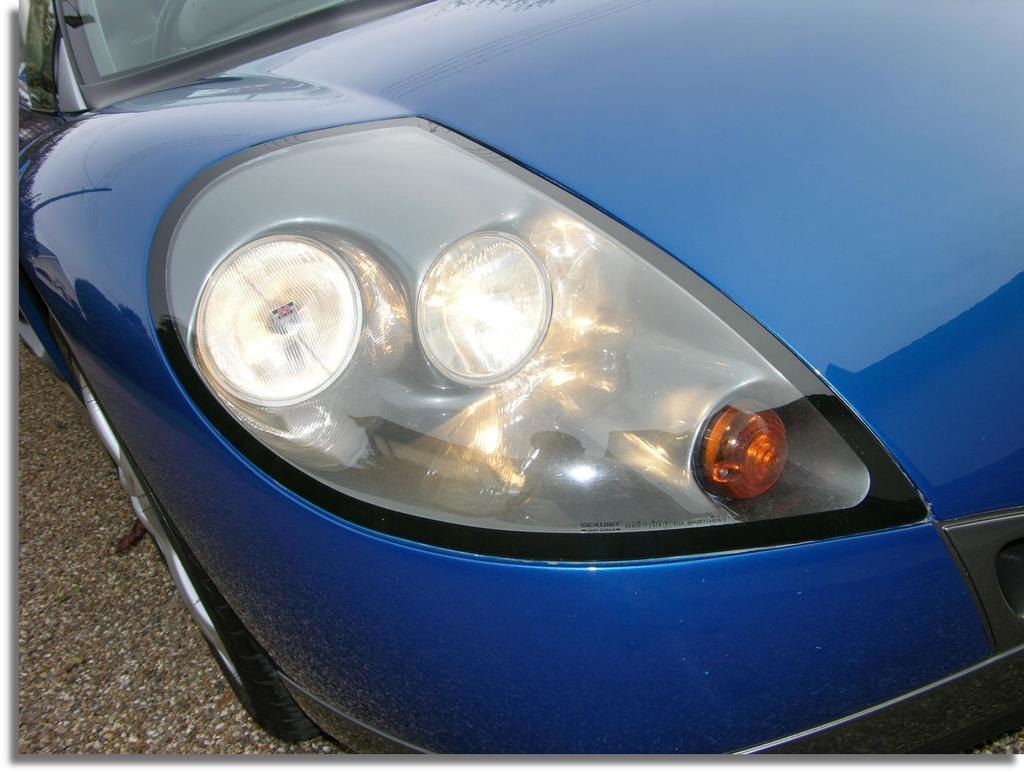What is the main subject in the foreground of the image? There is a car in the foreground of the image. What is the position of the car in relation to the ground? The car is on the ground. How is the car depicted in the image? The car is truncated. What type of powder is being used to clean the car in the image? There is no powder or cleaning activity depicted in the image; it only shows a truncated car on the ground. 